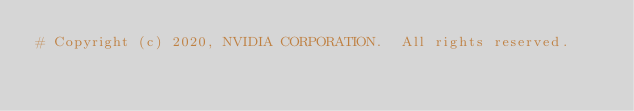Convert code to text. <code><loc_0><loc_0><loc_500><loc_500><_Python_># Copyright (c) 2020, NVIDIA CORPORATION.  All rights reserved.</code> 